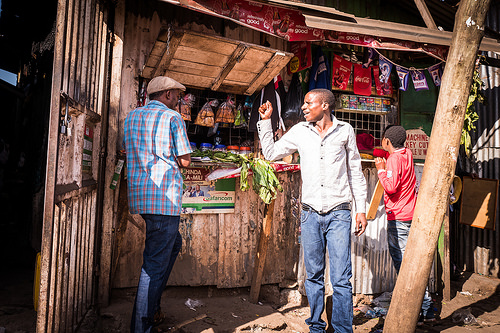<image>
Is the man to the right of the beam? Yes. From this viewpoint, the man is positioned to the right side relative to the beam. Where is the man in relation to the street market? Is it in the street market? Yes. The man is contained within or inside the street market, showing a containment relationship. 